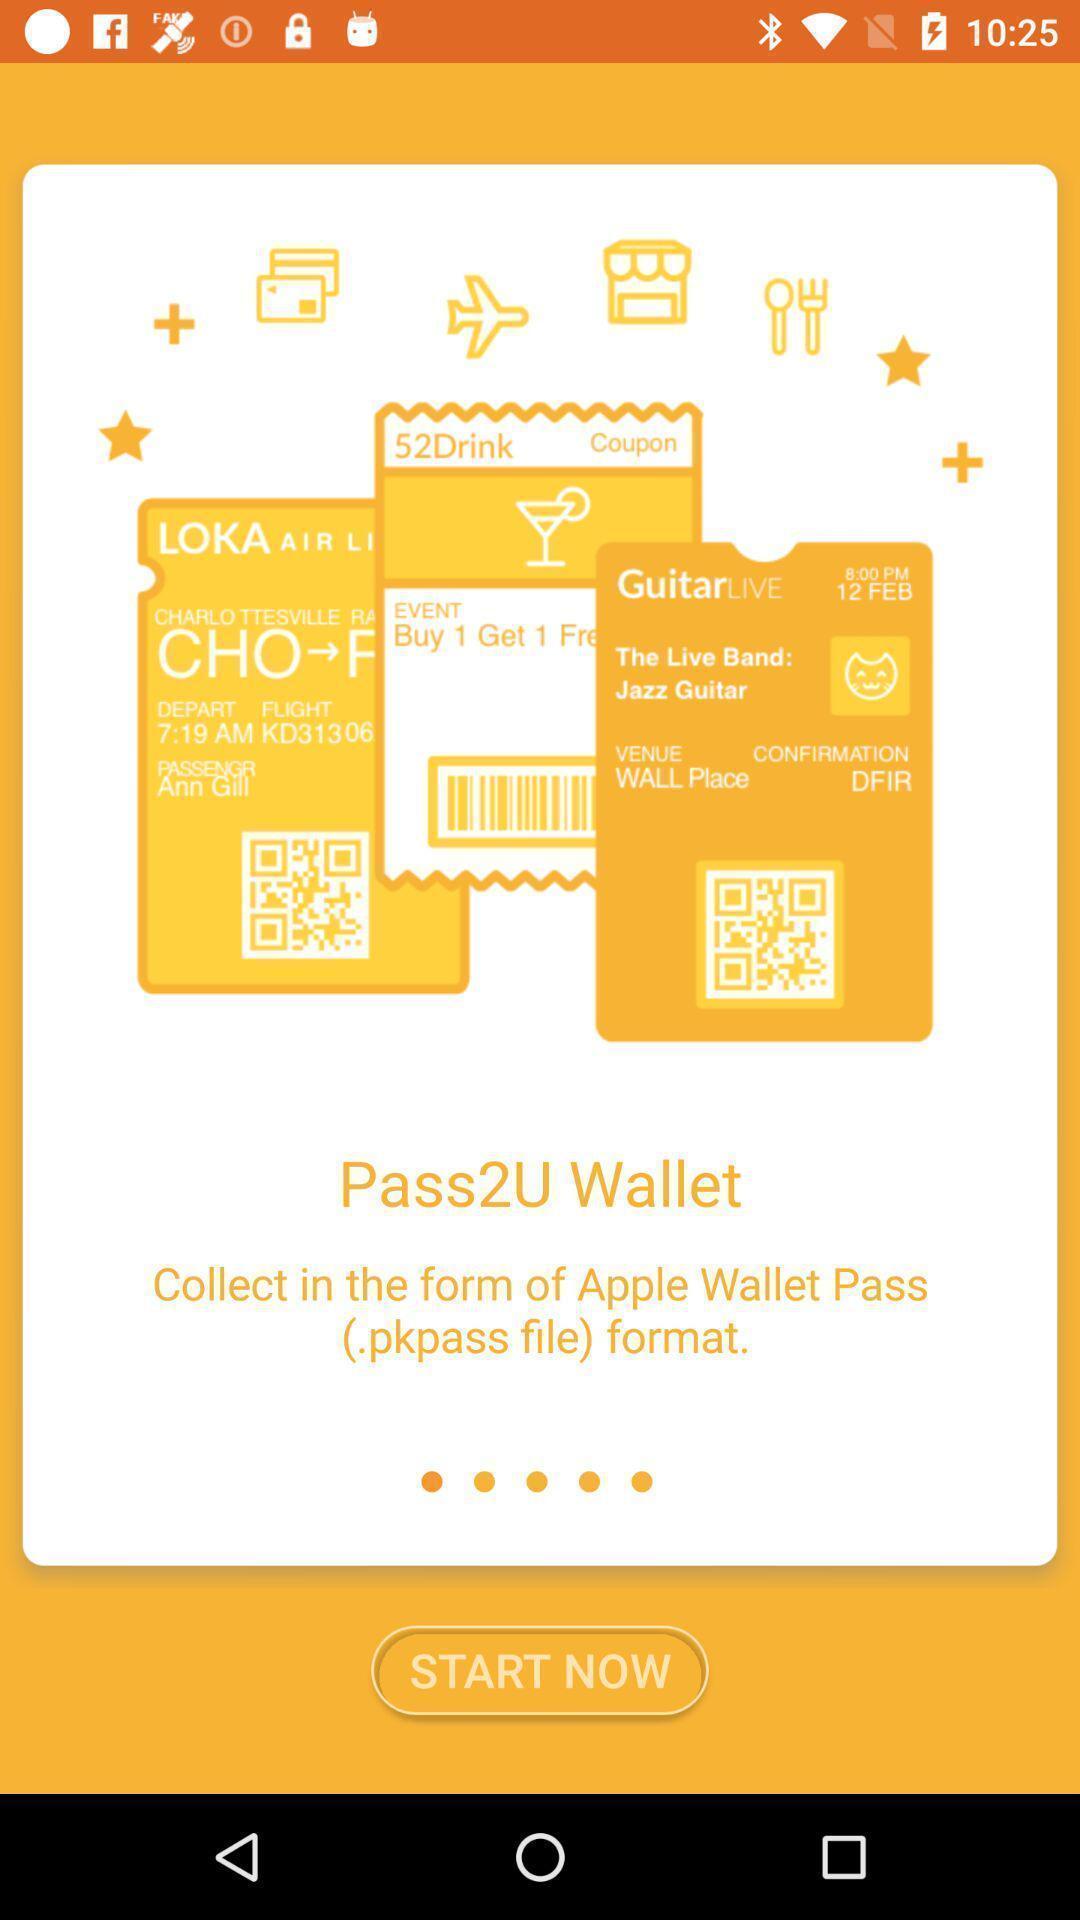Explain the elements present in this screenshot. Welcome page for a wallet app. 